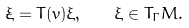Convert formula to latex. <formula><loc_0><loc_0><loc_500><loc_500>\dot { \xi } = T ( v ) \xi , \quad \xi \in T _ { \Gamma } M .</formula> 